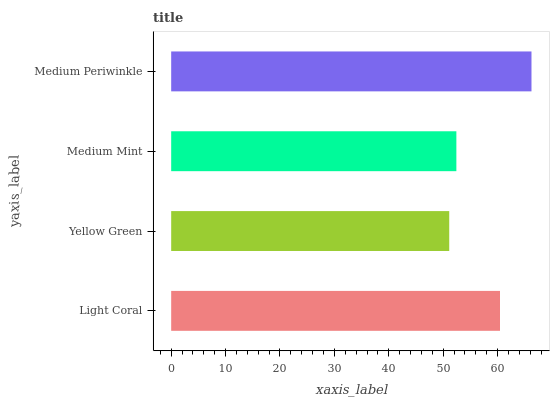Is Yellow Green the minimum?
Answer yes or no. Yes. Is Medium Periwinkle the maximum?
Answer yes or no. Yes. Is Medium Mint the minimum?
Answer yes or no. No. Is Medium Mint the maximum?
Answer yes or no. No. Is Medium Mint greater than Yellow Green?
Answer yes or no. Yes. Is Yellow Green less than Medium Mint?
Answer yes or no. Yes. Is Yellow Green greater than Medium Mint?
Answer yes or no. No. Is Medium Mint less than Yellow Green?
Answer yes or no. No. Is Light Coral the high median?
Answer yes or no. Yes. Is Medium Mint the low median?
Answer yes or no. Yes. Is Yellow Green the high median?
Answer yes or no. No. Is Yellow Green the low median?
Answer yes or no. No. 